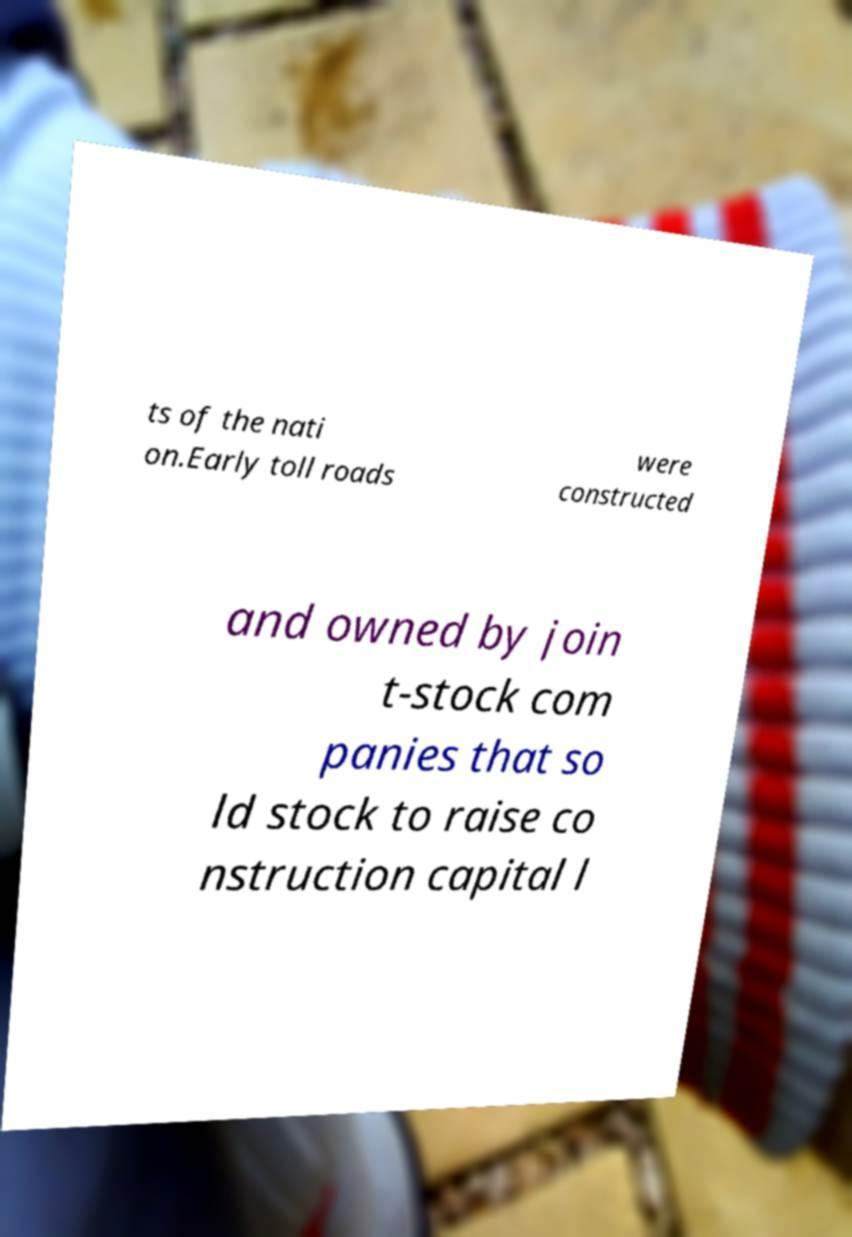Can you accurately transcribe the text from the provided image for me? ts of the nati on.Early toll roads were constructed and owned by join t-stock com panies that so ld stock to raise co nstruction capital l 